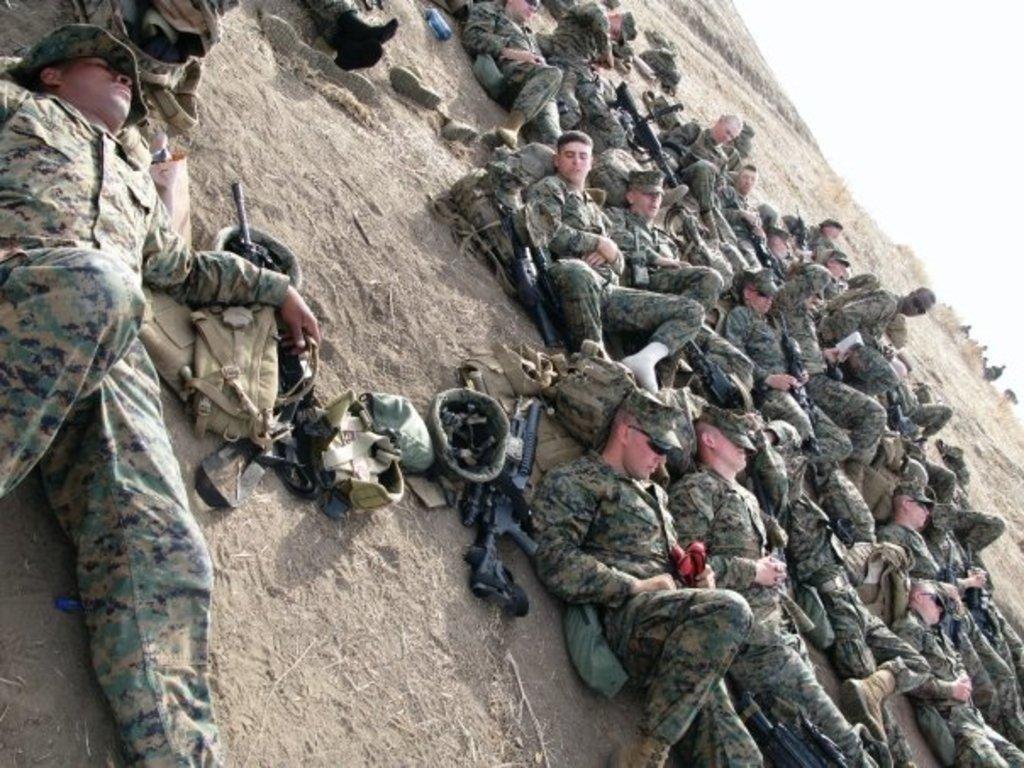In one or two sentences, can you explain what this image depicts? In this picture we can see there is a group of people lying on the ground and on the ground there are guns, a bottle and some objects. At the top right corner of the image, there is the sky. 